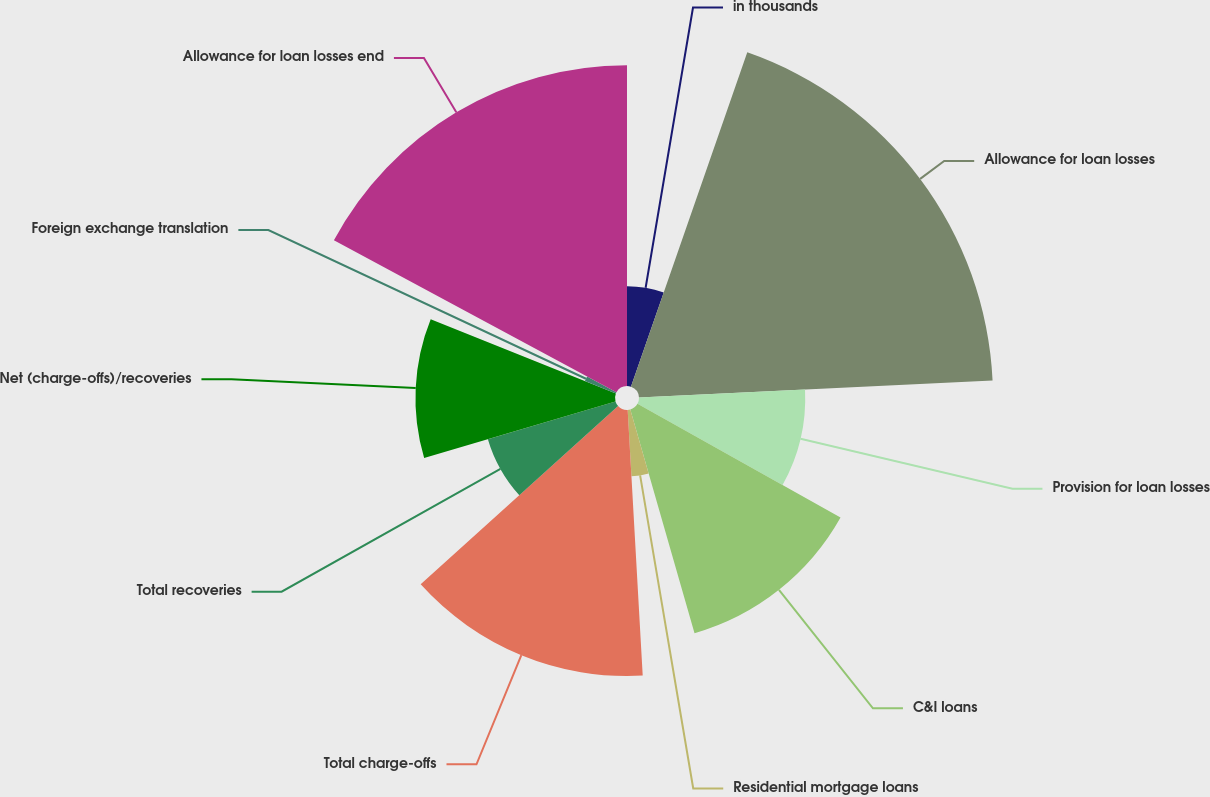<chart> <loc_0><loc_0><loc_500><loc_500><pie_chart><fcel>in thousands<fcel>Allowance for loan losses<fcel>Provision for loan losses<fcel>C&I loans<fcel>Residential mortgage loans<fcel>Total charge-offs<fcel>Total recoveries<fcel>Net (charge-offs)/recoveries<fcel>Foreign exchange translation<fcel>Allowance for loan losses end<nl><fcel>5.33%<fcel>18.91%<fcel>8.88%<fcel>12.43%<fcel>3.55%<fcel>14.21%<fcel>7.11%<fcel>10.66%<fcel>1.78%<fcel>17.14%<nl></chart> 